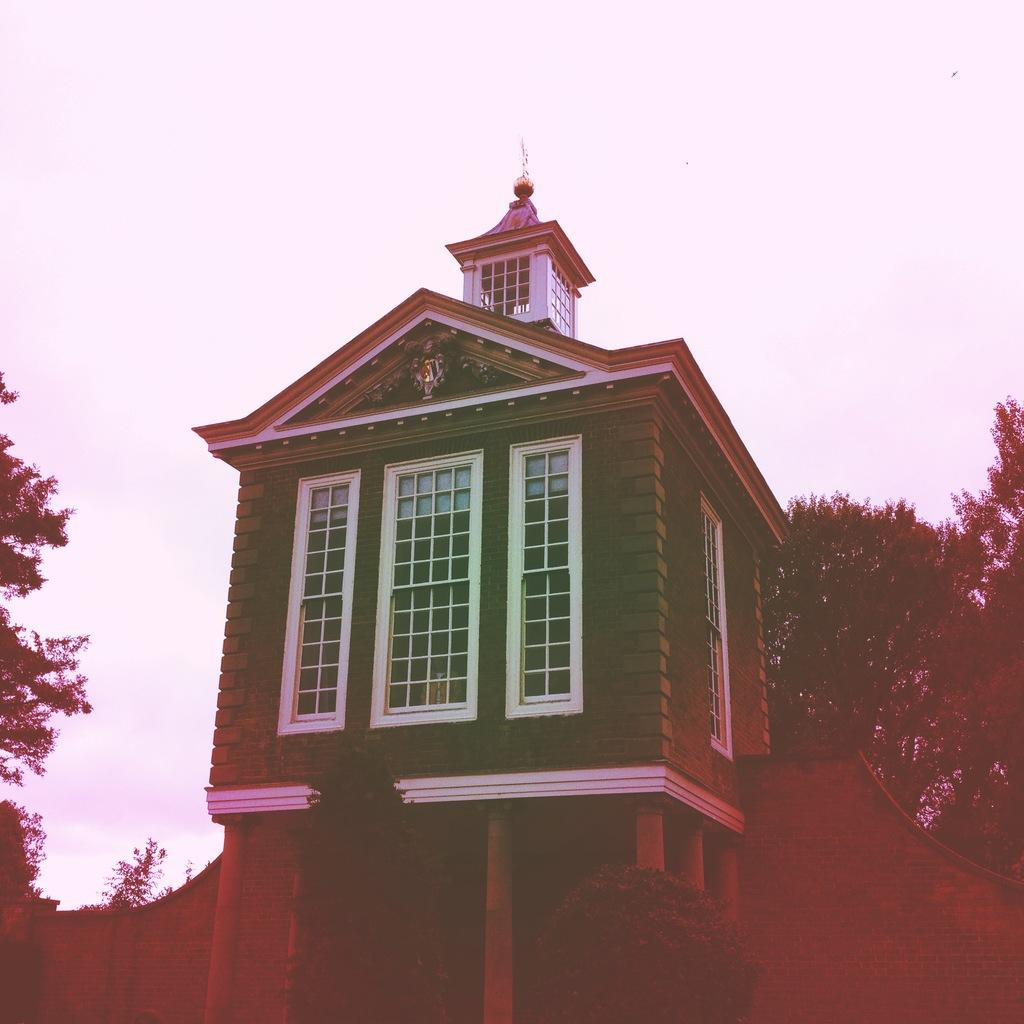What type of structure is visible in the image? There is a building in the image. What is located behind the building in the image? There is a wall at the back of the image. What type of vegetation can be seen on both sides of the image? There are trees on the right side and the left side of the image. What is visible at the top of the image? The sky is visible at the top of the image. What statement does the bubble make in the image? There is no bubble present in the image, so it cannot make any statements. 